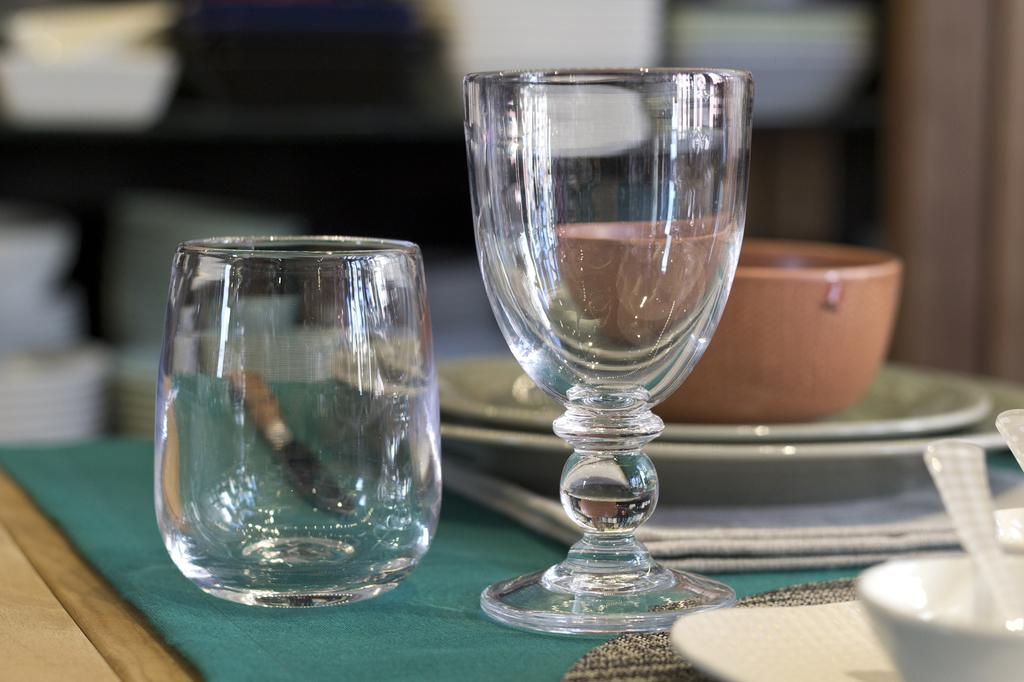How many glasses can be seen in the image? There are two glasses in the image. What else is present on the table besides the glasses? There is a bowl on plates, a napkin, and spoons in a bowl in the image. Where are the spoons located in the image? The spoons are in a bowl in the image. On what surface are the objects placed in the image? The objects are on top of a table in the image. Are there any fairies visible in the image? No, there are no fairies present in the image. What type of crook can be seen using a club in the image? There is no crook or club present in the image. 